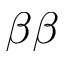Convert formula to latex. <formula><loc_0><loc_0><loc_500><loc_500>\beta \beta</formula> 